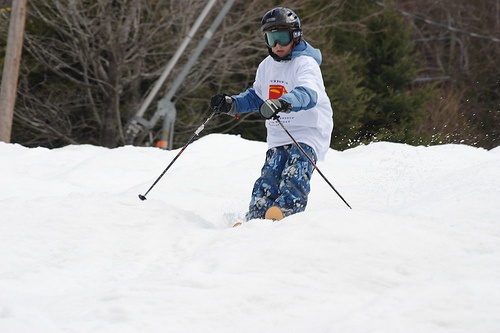Describe the objects in this image and their specific colors. I can see people in black, lavender, darkgray, and gray tones and skis in black, tan, and gray tones in this image. 